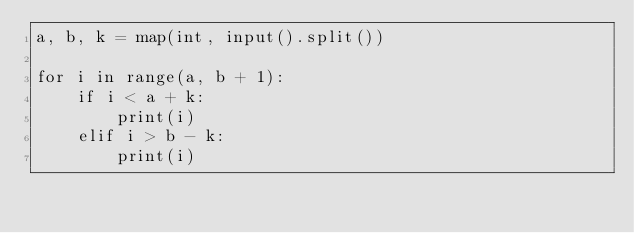<code> <loc_0><loc_0><loc_500><loc_500><_Python_>a, b, k = map(int, input().split())

for i in range(a, b + 1):
    if i < a + k:
        print(i)
    elif i > b - k:
        print(i)</code> 